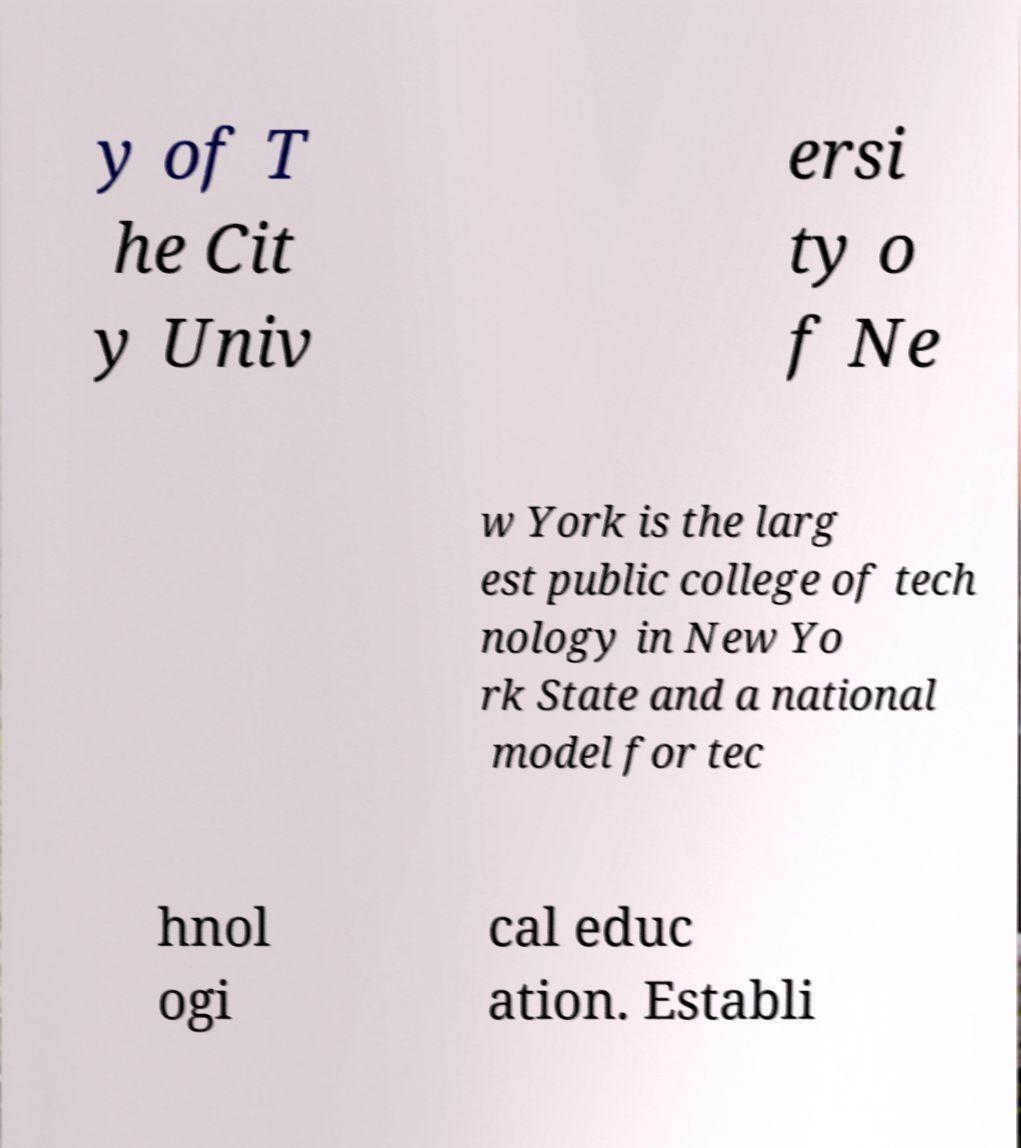Please identify and transcribe the text found in this image. y of T he Cit y Univ ersi ty o f Ne w York is the larg est public college of tech nology in New Yo rk State and a national model for tec hnol ogi cal educ ation. Establi 